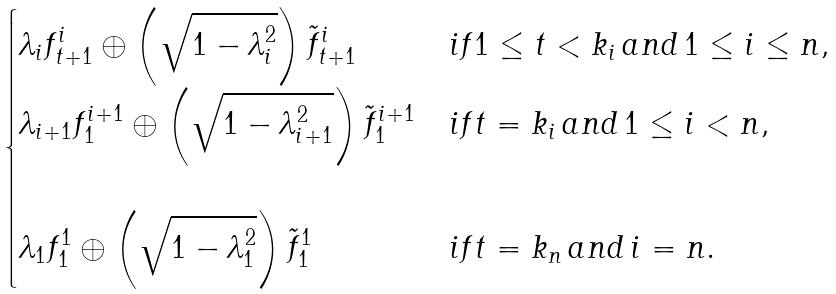Convert formula to latex. <formula><loc_0><loc_0><loc_500><loc_500>\begin{cases} \lambda _ { i } f ^ { i } _ { t + 1 } \oplus \left ( \sqrt { 1 - \lambda _ { i } ^ { 2 } } \right ) \tilde { f } ^ { i } _ { t + 1 } & i f 1 \leq t < k _ { i } \, a n d \, 1 \leq i \leq n , \\ \lambda _ { i + 1 } f ^ { i + 1 } _ { 1 } \oplus \left ( \sqrt { 1 - \lambda _ { i + 1 } ^ { 2 } } \right ) \tilde { f } ^ { i + 1 } _ { 1 } & i f t = k _ { i } \, a n d \, 1 \leq i < n , \\ \\ \lambda _ { 1 } f ^ { 1 } _ { 1 } \oplus \left ( \sqrt { 1 - \lambda _ { 1 } ^ { 2 } } \right ) \tilde { f } ^ { 1 } _ { 1 } & i f t = k _ { n } \, a n d \, i = n . \end{cases}</formula> 